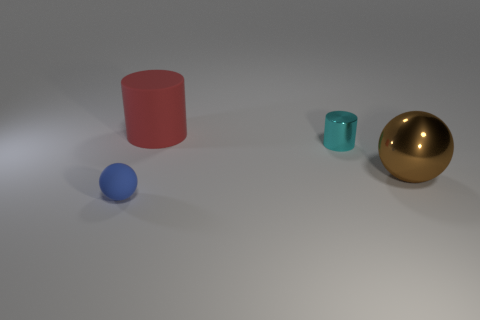Add 4 small blue matte objects. How many objects exist? 8 Subtract all brown balls. How many balls are left? 1 Subtract 1 cylinders. How many cylinders are left? 1 Add 4 cyan things. How many cyan things exist? 5 Subtract 1 blue spheres. How many objects are left? 3 Subtract all purple balls. Subtract all purple cylinders. How many balls are left? 2 Subtract all red cylinders. How many brown spheres are left? 1 Subtract all large green balls. Subtract all tiny matte objects. How many objects are left? 3 Add 2 blue spheres. How many blue spheres are left? 3 